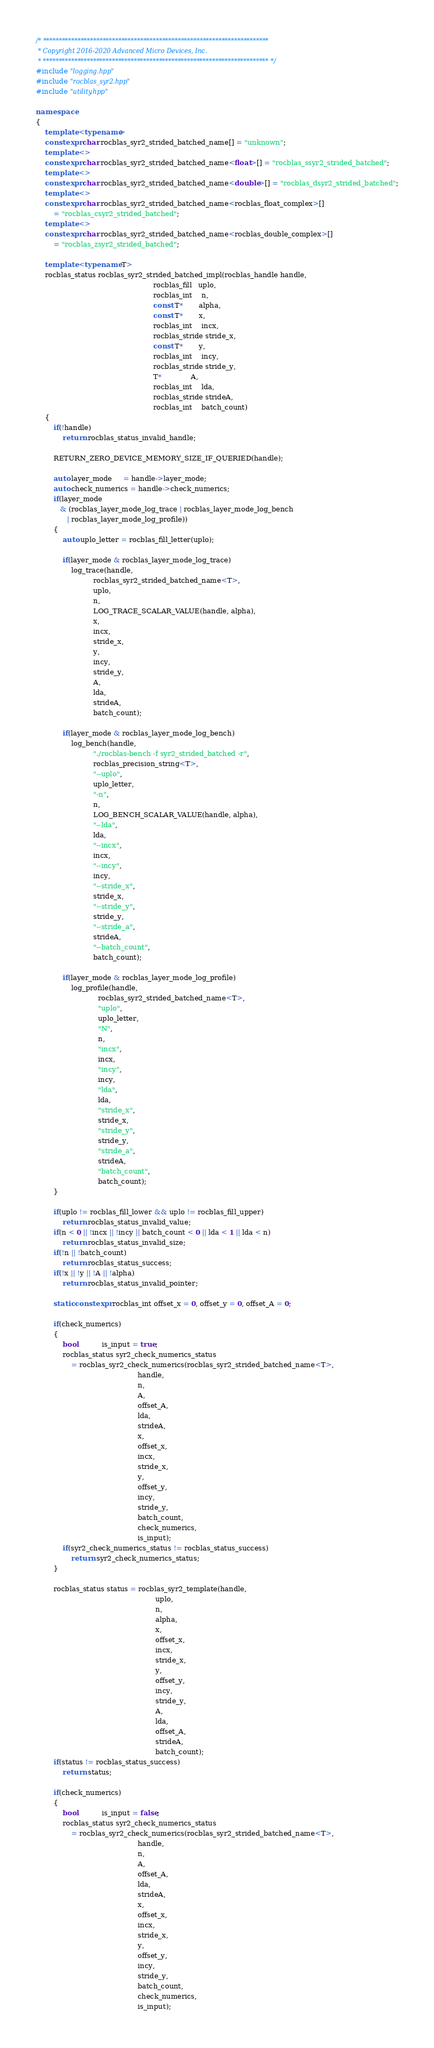Convert code to text. <code><loc_0><loc_0><loc_500><loc_500><_C++_>/* ************************************************************************
 * Copyright 2016-2020 Advanced Micro Devices, Inc.
 * ************************************************************************ */
#include "logging.hpp"
#include "rocblas_syr2.hpp"
#include "utility.hpp"

namespace
{
    template <typename>
    constexpr char rocblas_syr2_strided_batched_name[] = "unknown";
    template <>
    constexpr char rocblas_syr2_strided_batched_name<float>[] = "rocblas_ssyr2_strided_batched";
    template <>
    constexpr char rocblas_syr2_strided_batched_name<double>[] = "rocblas_dsyr2_strided_batched";
    template <>
    constexpr char rocblas_syr2_strided_batched_name<rocblas_float_complex>[]
        = "rocblas_csyr2_strided_batched";
    template <>
    constexpr char rocblas_syr2_strided_batched_name<rocblas_double_complex>[]
        = "rocblas_zsyr2_strided_batched";

    template <typename T>
    rocblas_status rocblas_syr2_strided_batched_impl(rocblas_handle handle,
                                                     rocblas_fill   uplo,
                                                     rocblas_int    n,
                                                     const T*       alpha,
                                                     const T*       x,
                                                     rocblas_int    incx,
                                                     rocblas_stride stride_x,
                                                     const T*       y,
                                                     rocblas_int    incy,
                                                     rocblas_stride stride_y,
                                                     T*             A,
                                                     rocblas_int    lda,
                                                     rocblas_stride strideA,
                                                     rocblas_int    batch_count)
    {
        if(!handle)
            return rocblas_status_invalid_handle;

        RETURN_ZERO_DEVICE_MEMORY_SIZE_IF_QUERIED(handle);

        auto layer_mode     = handle->layer_mode;
        auto check_numerics = handle->check_numerics;
        if(layer_mode
           & (rocblas_layer_mode_log_trace | rocblas_layer_mode_log_bench
              | rocblas_layer_mode_log_profile))
        {
            auto uplo_letter = rocblas_fill_letter(uplo);

            if(layer_mode & rocblas_layer_mode_log_trace)
                log_trace(handle,
                          rocblas_syr2_strided_batched_name<T>,
                          uplo,
                          n,
                          LOG_TRACE_SCALAR_VALUE(handle, alpha),
                          x,
                          incx,
                          stride_x,
                          y,
                          incy,
                          stride_y,
                          A,
                          lda,
                          strideA,
                          batch_count);

            if(layer_mode & rocblas_layer_mode_log_bench)
                log_bench(handle,
                          "./rocblas-bench -f syr2_strided_batched -r",
                          rocblas_precision_string<T>,
                          "--uplo",
                          uplo_letter,
                          "-n",
                          n,
                          LOG_BENCH_SCALAR_VALUE(handle, alpha),
                          "--lda",
                          lda,
                          "--incx",
                          incx,
                          "--incy",
                          incy,
                          "--stride_x",
                          stride_x,
                          "--stride_y",
                          stride_y,
                          "--stride_a",
                          strideA,
                          "--batch_count",
                          batch_count);

            if(layer_mode & rocblas_layer_mode_log_profile)
                log_profile(handle,
                            rocblas_syr2_strided_batched_name<T>,
                            "uplo",
                            uplo_letter,
                            "N",
                            n,
                            "incx",
                            incx,
                            "incy",
                            incy,
                            "lda",
                            lda,
                            "stride_x",
                            stride_x,
                            "stride_y",
                            stride_y,
                            "stride_a",
                            strideA,
                            "batch_count",
                            batch_count);
        }

        if(uplo != rocblas_fill_lower && uplo != rocblas_fill_upper)
            return rocblas_status_invalid_value;
        if(n < 0 || !incx || !incy || batch_count < 0 || lda < 1 || lda < n)
            return rocblas_status_invalid_size;
        if(!n || !batch_count)
            return rocblas_status_success;
        if(!x || !y || !A || !alpha)
            return rocblas_status_invalid_pointer;

        static constexpr rocblas_int offset_x = 0, offset_y = 0, offset_A = 0;

        if(check_numerics)
        {
            bool           is_input = true;
            rocblas_status syr2_check_numerics_status
                = rocblas_syr2_check_numerics(rocblas_syr2_strided_batched_name<T>,
                                              handle,
                                              n,
                                              A,
                                              offset_A,
                                              lda,
                                              strideA,
                                              x,
                                              offset_x,
                                              incx,
                                              stride_x,
                                              y,
                                              offset_y,
                                              incy,
                                              stride_y,
                                              batch_count,
                                              check_numerics,
                                              is_input);
            if(syr2_check_numerics_status != rocblas_status_success)
                return syr2_check_numerics_status;
        }

        rocblas_status status = rocblas_syr2_template(handle,
                                                      uplo,
                                                      n,
                                                      alpha,
                                                      x,
                                                      offset_x,
                                                      incx,
                                                      stride_x,
                                                      y,
                                                      offset_y,
                                                      incy,
                                                      stride_y,
                                                      A,
                                                      lda,
                                                      offset_A,
                                                      strideA,
                                                      batch_count);
        if(status != rocblas_status_success)
            return status;

        if(check_numerics)
        {
            bool           is_input = false;
            rocblas_status syr2_check_numerics_status
                = rocblas_syr2_check_numerics(rocblas_syr2_strided_batched_name<T>,
                                              handle,
                                              n,
                                              A,
                                              offset_A,
                                              lda,
                                              strideA,
                                              x,
                                              offset_x,
                                              incx,
                                              stride_x,
                                              y,
                                              offset_y,
                                              incy,
                                              stride_y,
                                              batch_count,
                                              check_numerics,
                                              is_input);</code> 